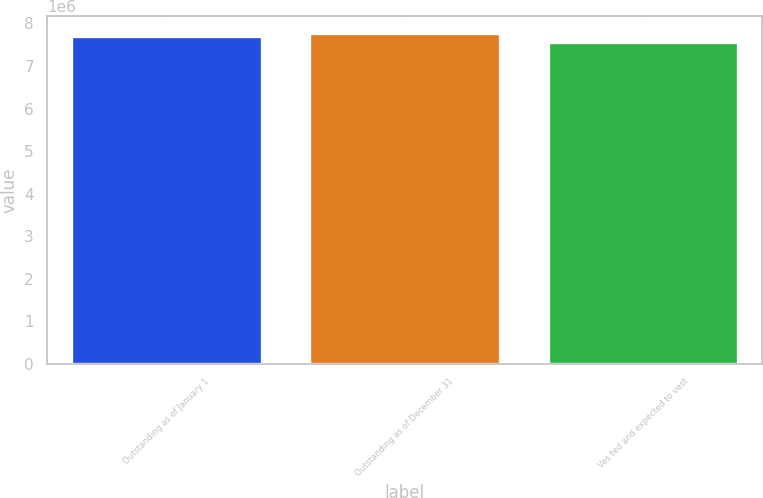<chart> <loc_0><loc_0><loc_500><loc_500><bar_chart><fcel>Outstanding as of January 1<fcel>Outstanding as of December 31<fcel>Ves ted and expected to vest<nl><fcel>7.70207e+06<fcel>7.77506e+06<fcel>7.55852e+06<nl></chart> 